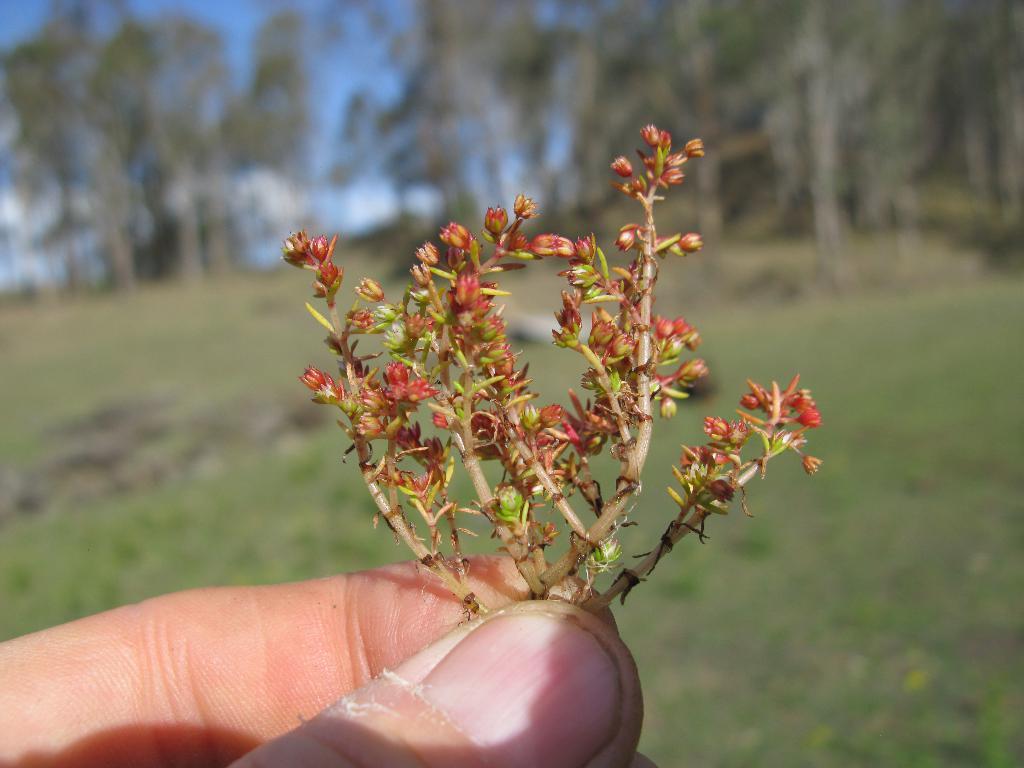Describe this image in one or two sentences. In this picture we can observe small flower buds. These flower buds were held by a human hand. We can observe some grass on the ground. In the background there are trees and a sky. 